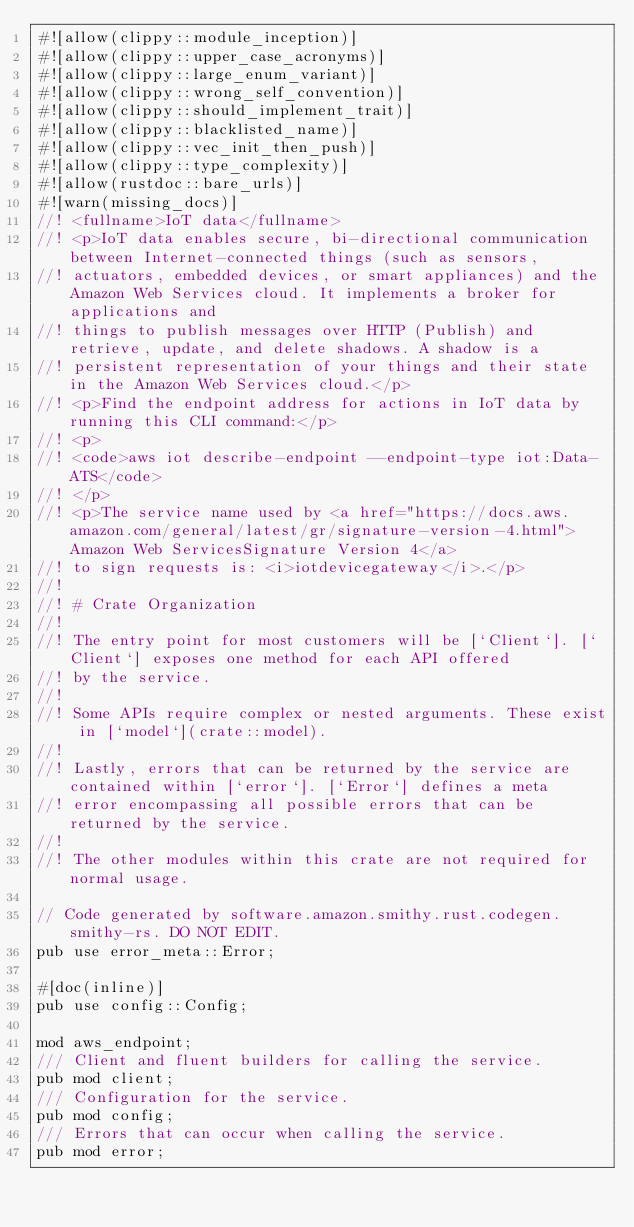Convert code to text. <code><loc_0><loc_0><loc_500><loc_500><_Rust_>#![allow(clippy::module_inception)]
#![allow(clippy::upper_case_acronyms)]
#![allow(clippy::large_enum_variant)]
#![allow(clippy::wrong_self_convention)]
#![allow(clippy::should_implement_trait)]
#![allow(clippy::blacklisted_name)]
#![allow(clippy::vec_init_then_push)]
#![allow(clippy::type_complexity)]
#![allow(rustdoc::bare_urls)]
#![warn(missing_docs)]
//! <fullname>IoT data</fullname>
//! <p>IoT data enables secure, bi-directional communication between Internet-connected things (such as sensors,
//! actuators, embedded devices, or smart appliances) and the Amazon Web Services cloud. It implements a broker for applications and
//! things to publish messages over HTTP (Publish) and retrieve, update, and delete shadows. A shadow is a
//! persistent representation of your things and their state in the Amazon Web Services cloud.</p>
//! <p>Find the endpoint address for actions in IoT data by running this CLI command:</p>
//! <p>
//! <code>aws iot describe-endpoint --endpoint-type iot:Data-ATS</code>
//! </p>
//! <p>The service name used by <a href="https://docs.aws.amazon.com/general/latest/gr/signature-version-4.html">Amazon Web ServicesSignature Version 4</a>
//! to sign requests is: <i>iotdevicegateway</i>.</p>
//!
//! # Crate Organization
//!
//! The entry point for most customers will be [`Client`]. [`Client`] exposes one method for each API offered
//! by the service.
//!
//! Some APIs require complex or nested arguments. These exist in [`model`](crate::model).
//!
//! Lastly, errors that can be returned by the service are contained within [`error`]. [`Error`] defines a meta
//! error encompassing all possible errors that can be returned by the service.
//!
//! The other modules within this crate are not required for normal usage.

// Code generated by software.amazon.smithy.rust.codegen.smithy-rs. DO NOT EDIT.
pub use error_meta::Error;

#[doc(inline)]
pub use config::Config;

mod aws_endpoint;
/// Client and fluent builders for calling the service.
pub mod client;
/// Configuration for the service.
pub mod config;
/// Errors that can occur when calling the service.
pub mod error;</code> 